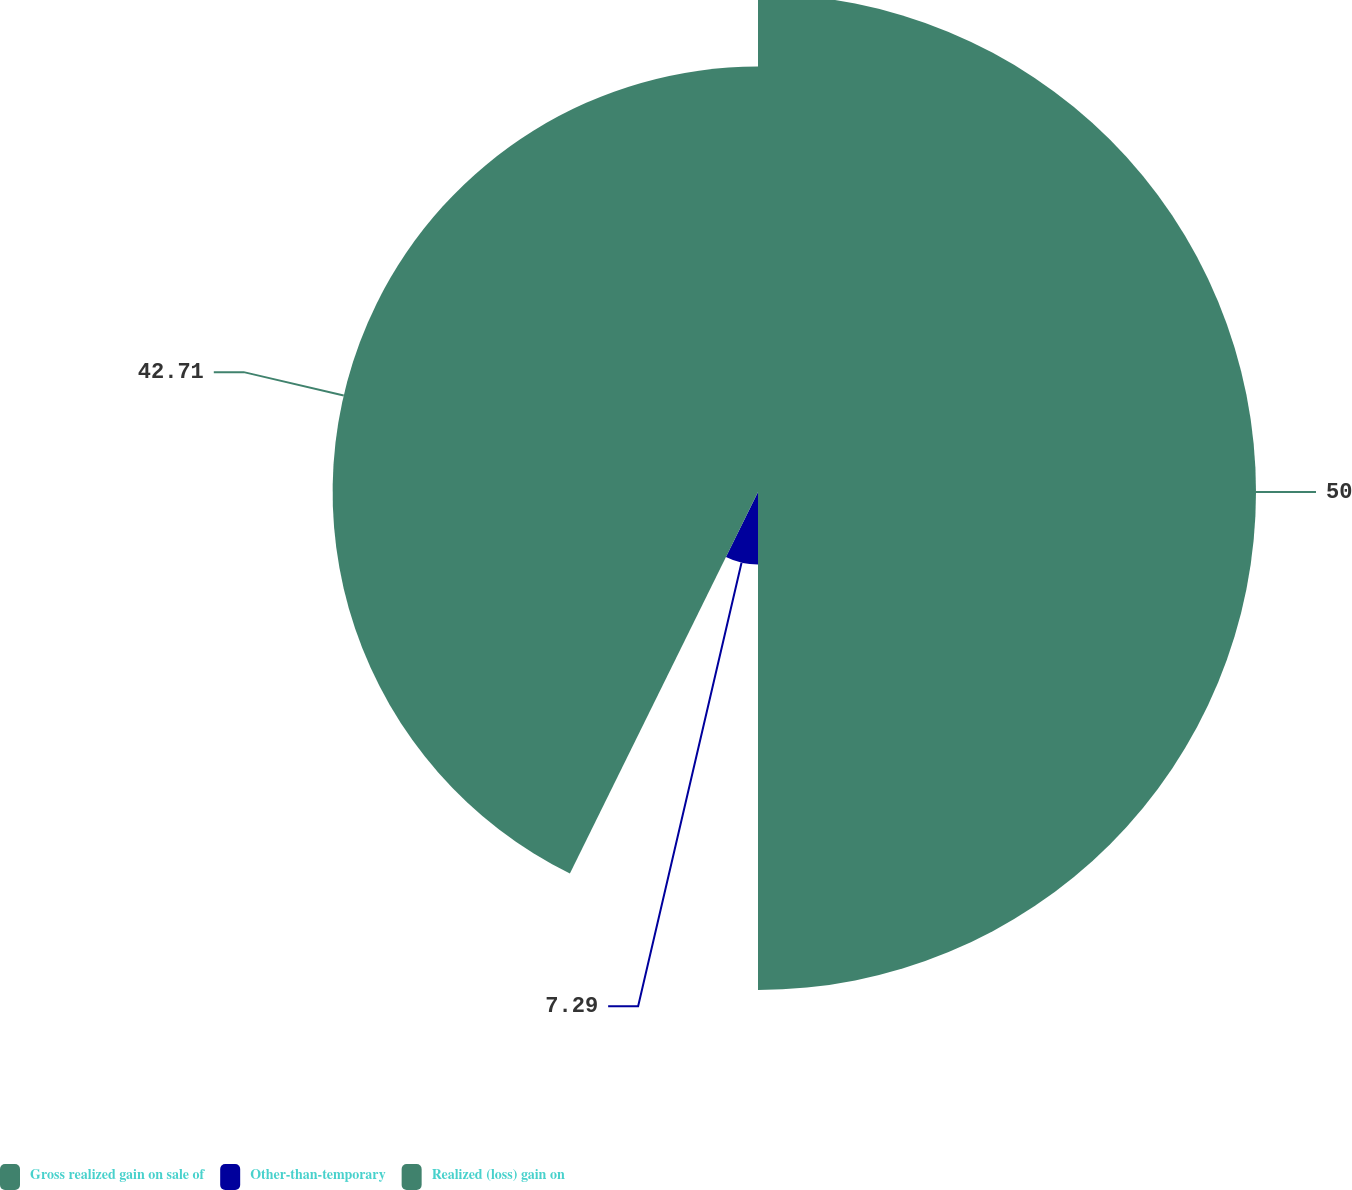Convert chart. <chart><loc_0><loc_0><loc_500><loc_500><pie_chart><fcel>Gross realized gain on sale of<fcel>Other-than-temporary<fcel>Realized (loss) gain on<nl><fcel>50.0%<fcel>7.29%<fcel>42.71%<nl></chart> 